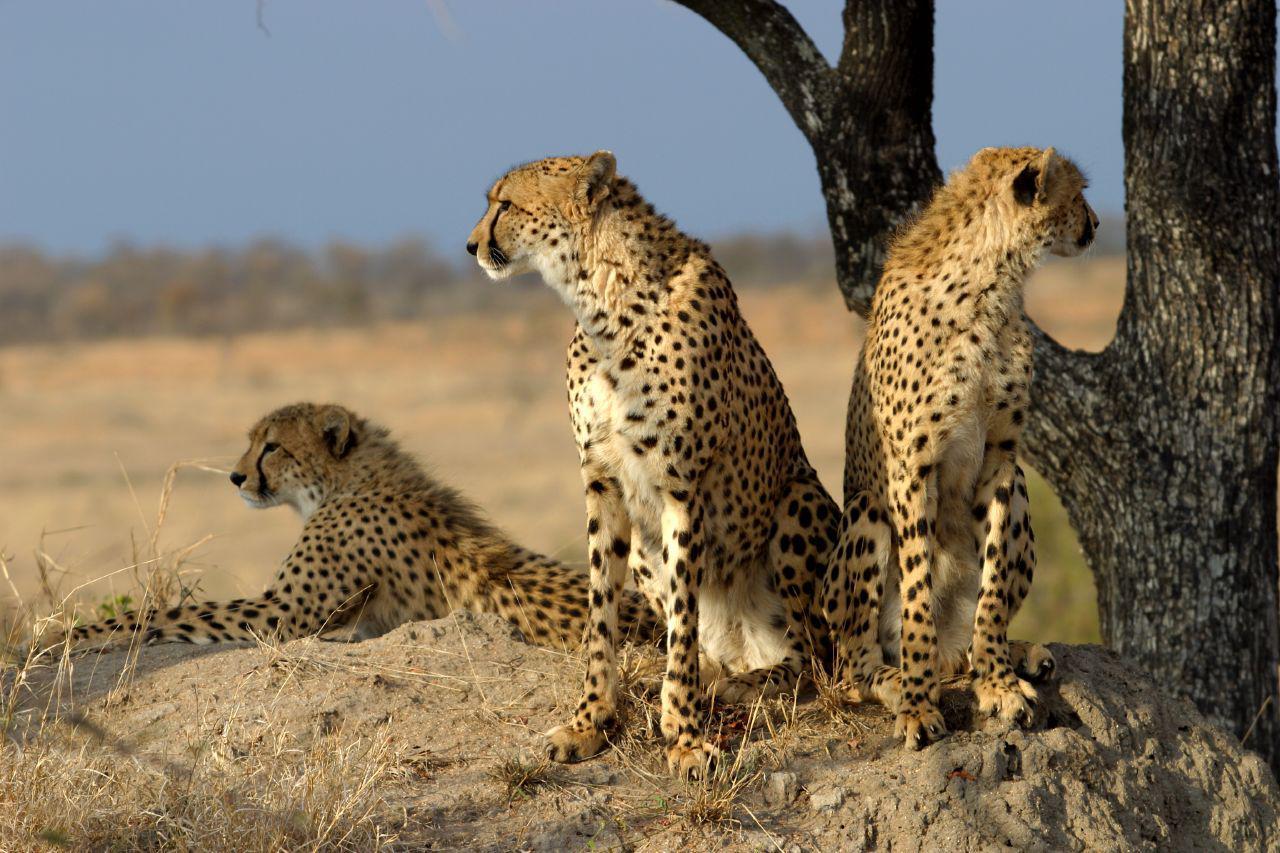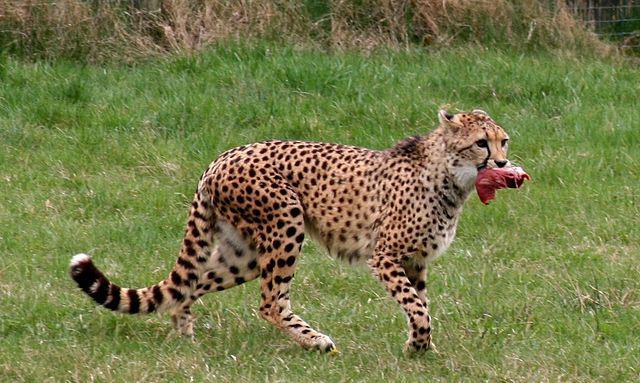The first image is the image on the left, the second image is the image on the right. Analyze the images presented: Is the assertion "More than one cat in the image on the left is lying down." valid? Answer yes or no. No. The first image is the image on the left, the second image is the image on the right. Assess this claim about the two images: "The left photo contains three or more cheetahs.". Correct or not? Answer yes or no. Yes. 